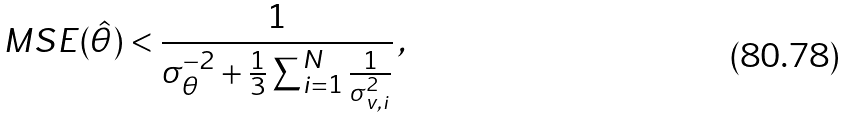Convert formula to latex. <formula><loc_0><loc_0><loc_500><loc_500>M S E ( \hat { \theta } ) < \frac { 1 } { \sigma _ { \theta } ^ { - 2 } + \frac { 1 } { 3 } \sum _ { i = 1 } ^ { N } \frac { 1 } { \sigma _ { v , i } ^ { 2 } } } \, ,</formula> 